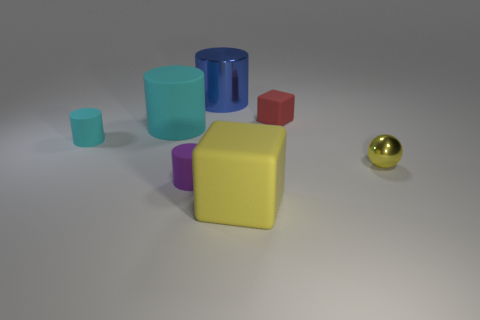How big is the cube behind the yellow matte block?
Offer a very short reply. Small. Is the color of the metal thing in front of the blue cylinder the same as the rubber cube in front of the purple cylinder?
Provide a short and direct response. Yes. Is there anything else that has the same color as the large rubber block?
Your answer should be very brief. Yes. What is the color of the object that is behind the tiny cyan matte thing and right of the yellow block?
Provide a succinct answer. Red. There is a shiny object that is left of the yellow matte object; is it the same size as the large yellow thing?
Ensure brevity in your answer.  Yes. Are there more yellow objects that are left of the tiny red cube than gray rubber cylinders?
Provide a short and direct response. Yes. Is the big metal object the same shape as the large cyan thing?
Ensure brevity in your answer.  Yes. What is the size of the yellow rubber cube?
Offer a terse response. Large. Are there more small cyan objects that are left of the yellow block than metallic cylinders that are behind the large metal cylinder?
Make the answer very short. Yes. There is a purple cylinder; are there any yellow objects behind it?
Offer a very short reply. Yes. 